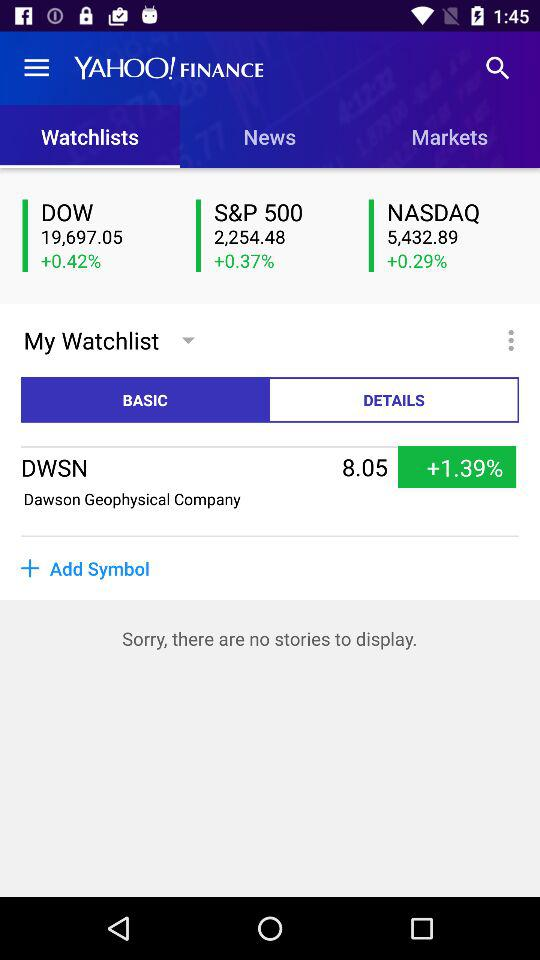Which one is selected out of "BASIC" and "DETAILS"? The selected one is "BASIC". 